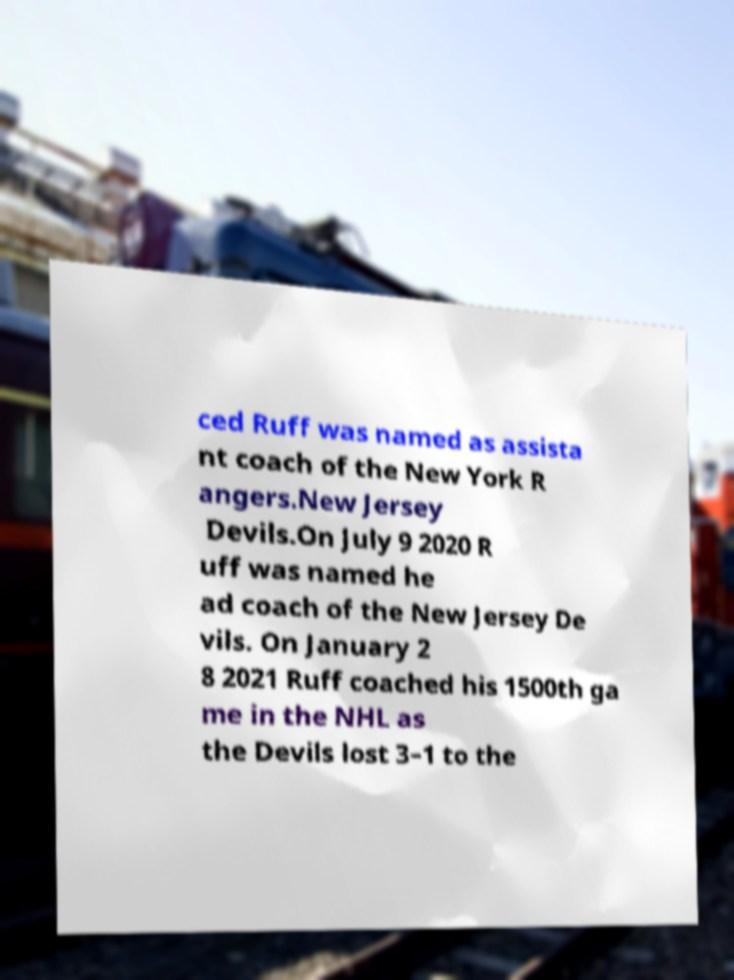There's text embedded in this image that I need extracted. Can you transcribe it verbatim? ced Ruff was named as assista nt coach of the New York R angers.New Jersey Devils.On July 9 2020 R uff was named he ad coach of the New Jersey De vils. On January 2 8 2021 Ruff coached his 1500th ga me in the NHL as the Devils lost 3–1 to the 